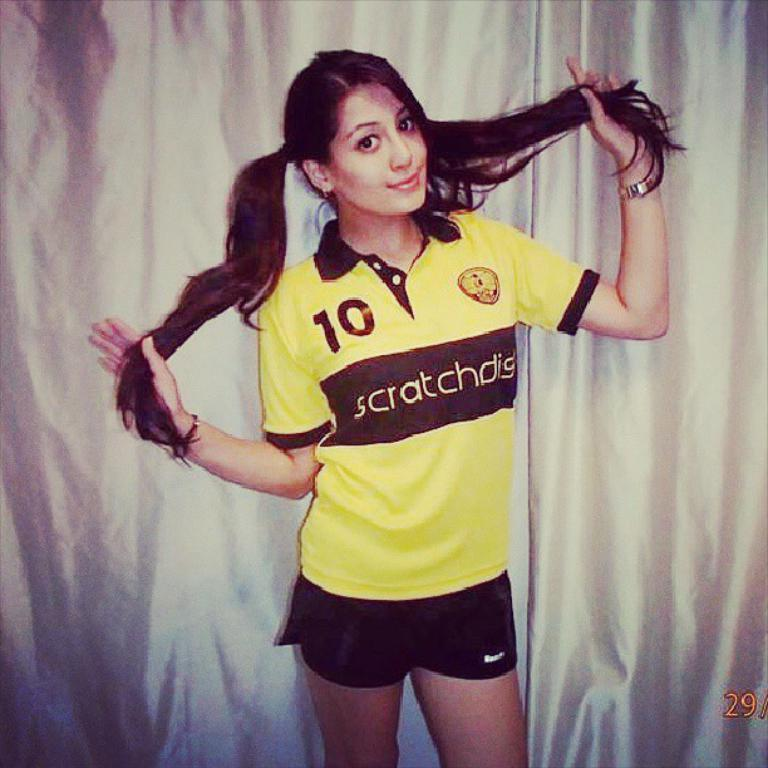<image>
Present a compact description of the photo's key features. A girl standing with her hair in pig tails and wearing a sports outfit that says SCRATCHDIG on the front. 